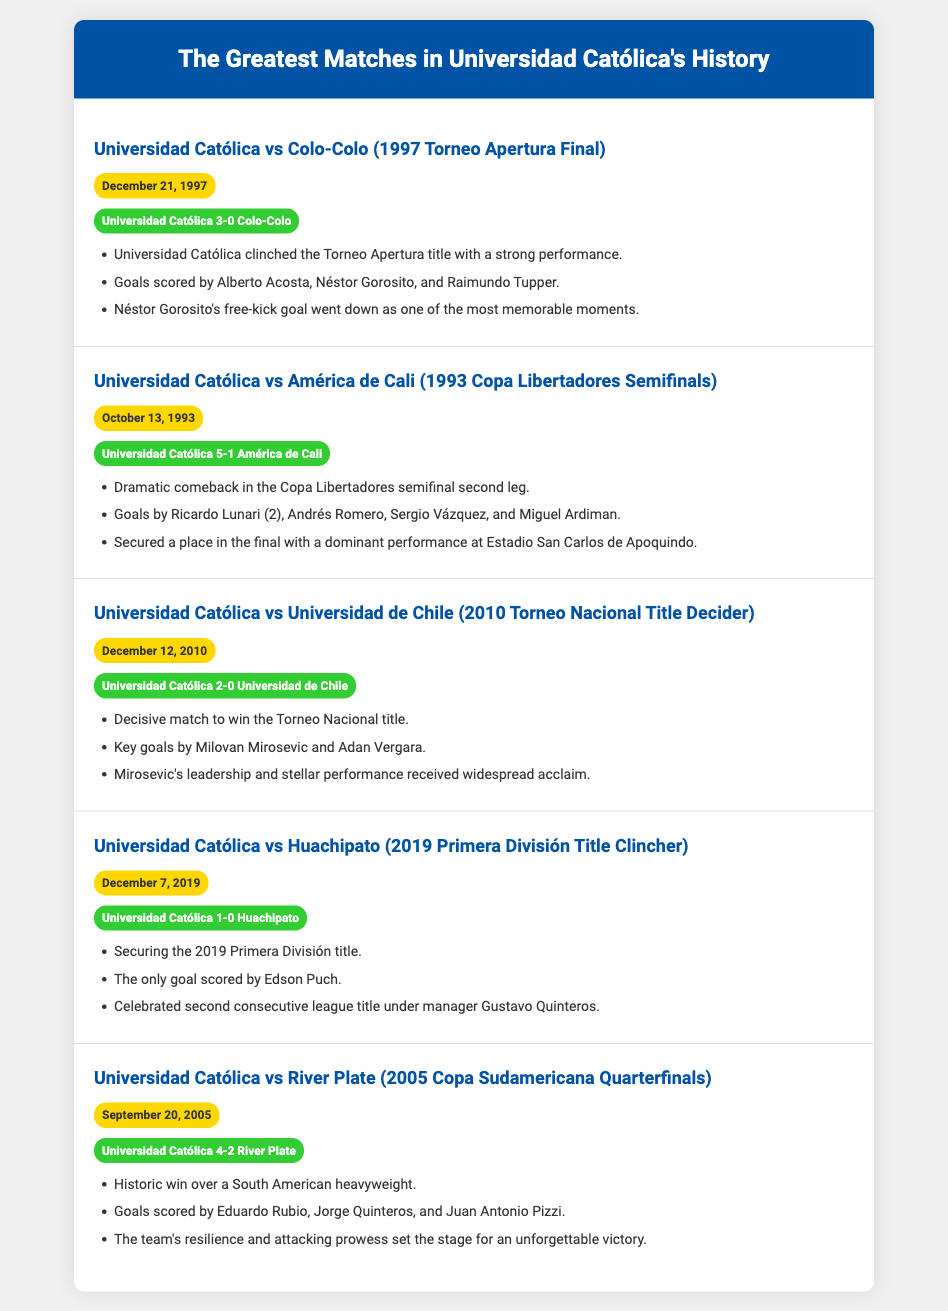What was the score of the match against Colo-Colo? The score of the match against Colo-Colo was mentioned in the document under the match title, indicating Universidad Católica won 3-0.
Answer: Universidad Católica 3-0 Colo-Colo Who scored the only goal against Huachipato? The highlights section for the match against Huachipato specifies that Edson Puch scored the only goal that led to the victory.
Answer: Edson Puch When did Universidad Católica clinch the Torneo Apertura title? The date is provided in the match details, stating that it was on December 21, 1997, during the final against Colo-Colo.
Answer: December 21, 1997 How many goals did Ricardo Lunari score against América de Cali? The document lists that Ricardo Lunari scored 2 goals in the match against América de Cali, as part of a list of scorers.
Answer: 2 Which match secured the 2019 Primera División title? The document indicates that the match against Huachipato on December 7, 2019, was the one that secured the title.
Answer: Universidad Católica vs Huachipato What notable moment is highlighted in the match against Colo-Colo? The highlights for the match against Colo-Colo note that Néstor Gorosito's free-kick goal was remembered as one of the most memorable moments.
Answer: Néstor Gorosito's free-kick goal How many matches are listed in the document? By counting the match items presented, there are a total of 5 matches detailed in the document regarding Universidad Católica's history.
Answer: 5 Which two teams did Universidad Católica face in the 2010 Torneo Nacional title decider? The document specifies that Universidad Católica faced Universidad de Chile in the decisive match for the Torneo Nacional title.
Answer: Universidad de Chile 